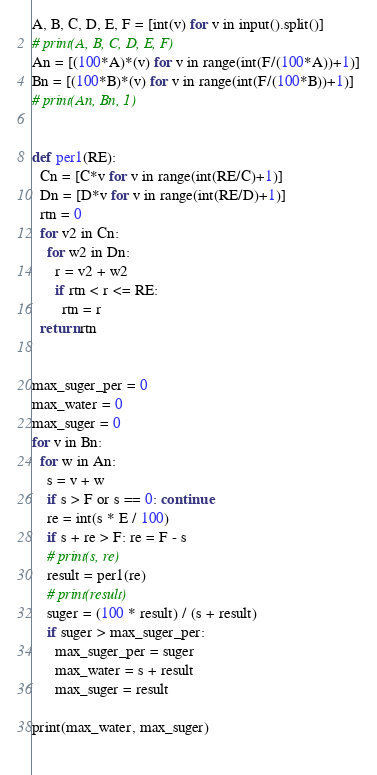Convert code to text. <code><loc_0><loc_0><loc_500><loc_500><_Python_>A, B, C, D, E, F = [int(v) for v in input().split()]
# print(A, B, C, D, E, F)
An = [(100*A)*(v) for v in range(int(F/(100*A))+1)]
Bn = [(100*B)*(v) for v in range(int(F/(100*B))+1)]
# print(An, Bn, 1)
 
 
def per1(RE):
  Cn = [C*v for v in range(int(RE/C)+1)]
  Dn = [D*v for v in range(int(RE/D)+1)]
  rtn = 0
  for v2 in Cn:
    for w2 in Dn:
      r = v2 + w2
      if rtn < r <= RE:
        rtn = r
  return rtn
  
  
max_suger_per = 0
max_water = 0
max_suger = 0
for v in Bn:
  for w in An:
    s = v + w
    if s > F or s == 0: continue
    re = int(s * E / 100)
    if s + re > F: re = F - s
    # print(s, re)
    result = per1(re)
    # print(result)
    suger = (100 * result) / (s + result)
    if suger > max_suger_per:
      max_suger_per = suger
      max_water = s + result
      max_suger = result
    
print(max_water, max_suger)
  </code> 